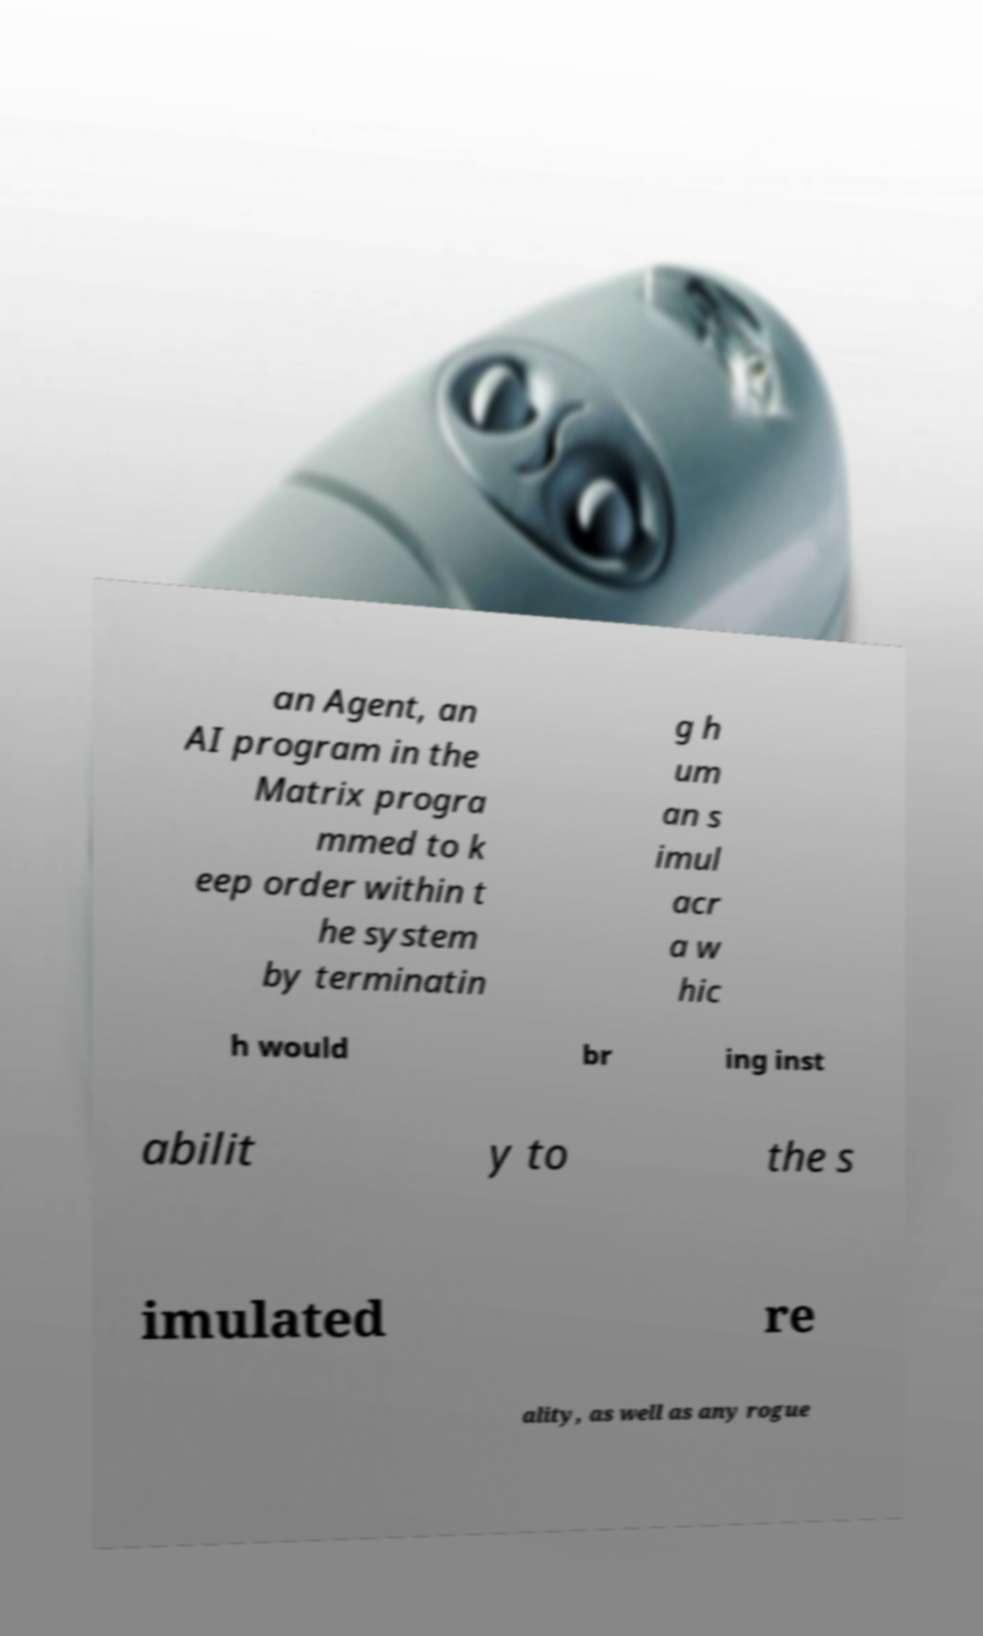There's text embedded in this image that I need extracted. Can you transcribe it verbatim? an Agent, an AI program in the Matrix progra mmed to k eep order within t he system by terminatin g h um an s imul acr a w hic h would br ing inst abilit y to the s imulated re ality, as well as any rogue 